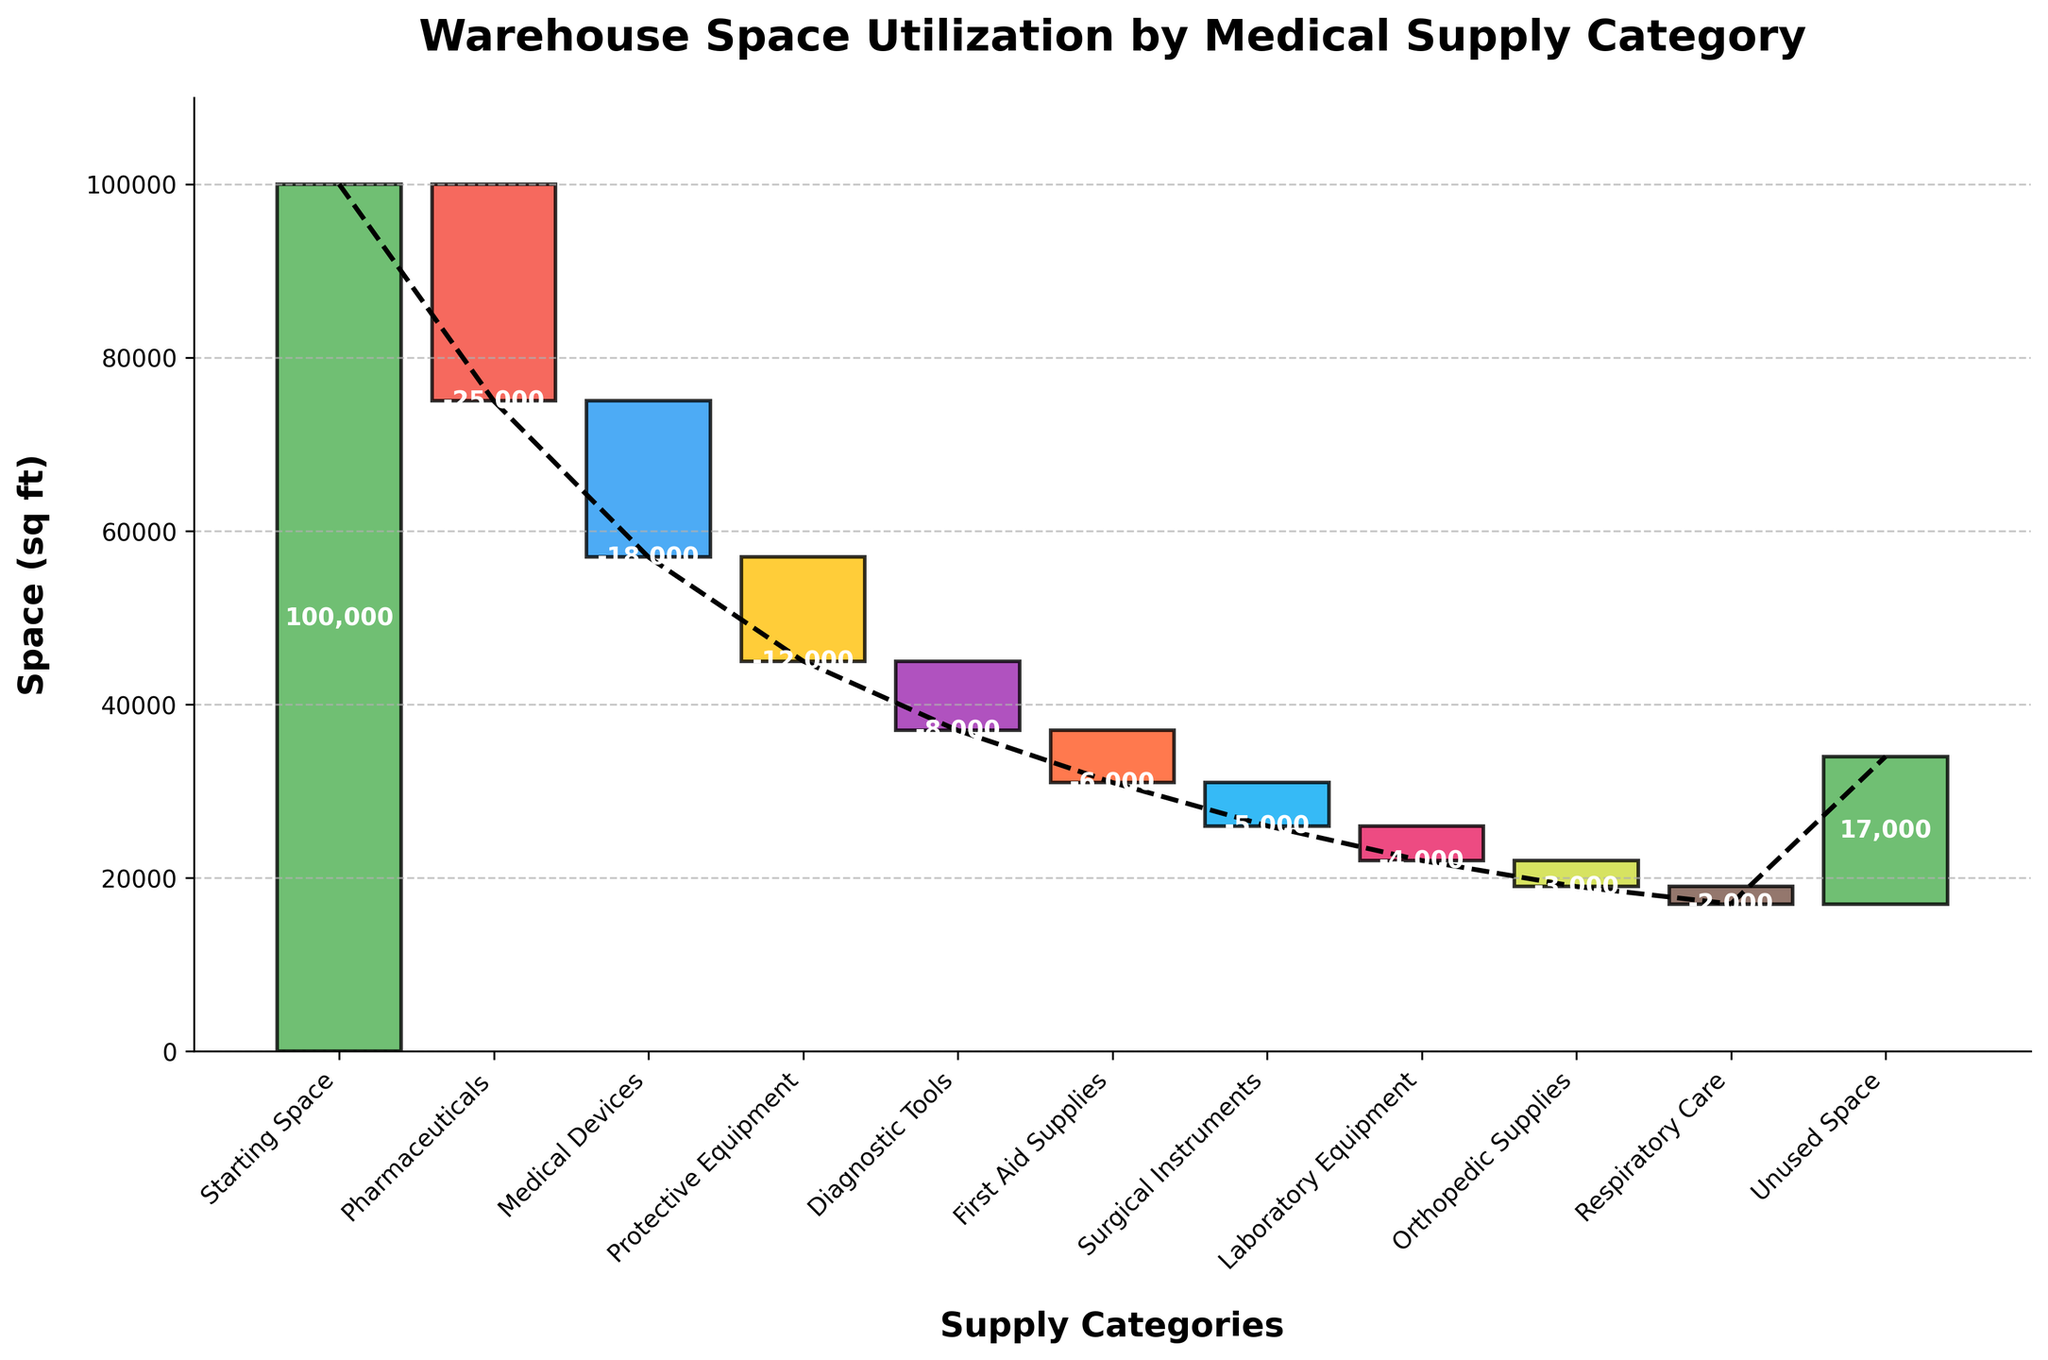How much space is utilized by Pharmaceuticals? Locate the bar labeled "Pharmaceuticals" on the chart and note the value written on the bar. The value indicates the space utilized by Pharmaceuticals.
Answer: 25,000 sq ft What is the total space utilized by Medical Devices and Protective Equipment? Identify the values for both "Medical Devices" (-18,000) and "Protective Equipment" (-12,000). Sum these values together.
Answer: 30,000 sq ft Which category utilizes more space: Diagnostic Tools or First Aid Supplies? Compare the values for "Diagnostic Tools" (-8,000) and "First Aid Supplies" (-6,000) on the chart. The category with the higher absolute value utilizes more space.
Answer: Diagnostic Tools What is the remaining unused space in the warehouse? Locate the value for "Unused Space" at the end of the chart. This value represents the remaining space.
Answer: 17,000 sq ft How does the space utilization for Orthopedic Supplies compare to that for Respiratory Care? Compare the values for "Orthopedic Supplies" (-3,000) and "Respiratory Care" (-2,000). Evaluate which has a greater magnitude.
Answer: Orthopedic Supplies What is the cumulative space utilized after adding Medical Devices? Identify the cumulative value after the "Medical Devices" bar. This value represents the total space used up to that category.
Answer: 43,000 sq ft By how much does the space utilization of Surgical Instruments decrease from First Aid Supplies? Compare the values for "First Aid Supplies" (-6,000) and "Surgical Instruments" (-5,000). Subtract the value of Surgical Instruments from First Aid Supplies to find the difference.
Answer: 1,000 sq ft How many categories demonstrate a reduction in space utilization? Count the number of categories with negative values, excluding "Starting Space" and "Unused Space".
Answer: 8 What percentage of the total starting space is utilized by Laboratory Equipment? Find the space for "Laboratory Equipment" (-4,000) and the "Starting Space" (100,000). Calculate the percentage by dividing the value of Laboratory Equipment by Starting Space and multiplying by 100.
Answer: 4% In which category is the space reduction closest to the mean reduction value of all categories? First, find the mean reduction value by summing all negative values and dividing by the number of categories. Then compare each category's space reduction to this mean.
Answer: Medical Devices 